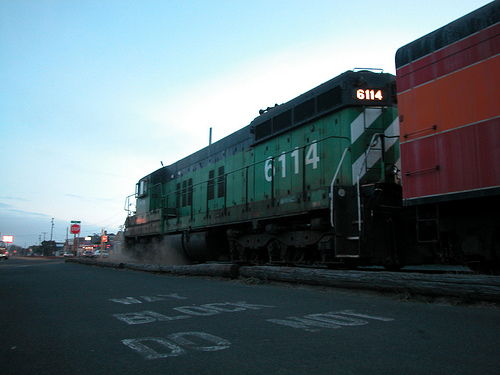Is the road that is not unpaved tan or black? The road that is paved in the image is black. 